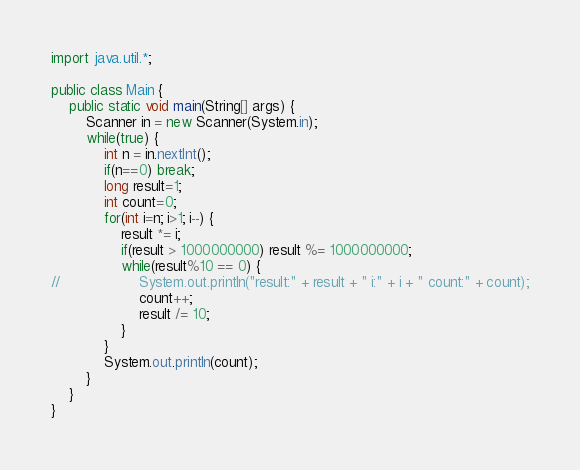Convert code to text. <code><loc_0><loc_0><loc_500><loc_500><_Java_>import java.util.*;

public class Main {
	public static void main(String[] args) {
		Scanner in = new Scanner(System.in);
		while(true) {
			int n = in.nextInt();
			if(n==0) break;
			long result=1;
			int count=0;
			for(int i=n; i>1; i--) {
				result *= i;
				if(result > 1000000000) result %= 1000000000;
				while(result%10 == 0) {
//					System.out.println("result:" + result + " i:" + i + " count:" + count);
					count++;
					result /= 10;
				}
			}
			System.out.println(count);
		}
	}
}</code> 